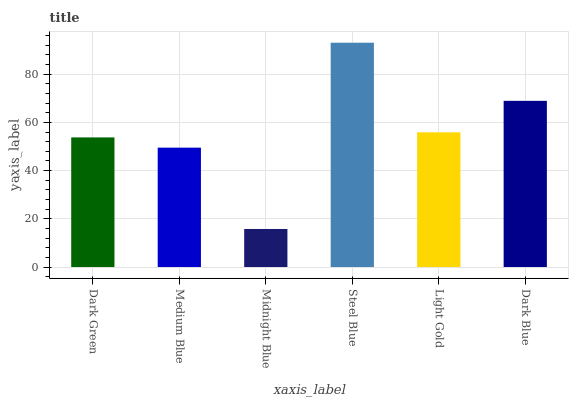Is Midnight Blue the minimum?
Answer yes or no. Yes. Is Steel Blue the maximum?
Answer yes or no. Yes. Is Medium Blue the minimum?
Answer yes or no. No. Is Medium Blue the maximum?
Answer yes or no. No. Is Dark Green greater than Medium Blue?
Answer yes or no. Yes. Is Medium Blue less than Dark Green?
Answer yes or no. Yes. Is Medium Blue greater than Dark Green?
Answer yes or no. No. Is Dark Green less than Medium Blue?
Answer yes or no. No. Is Light Gold the high median?
Answer yes or no. Yes. Is Dark Green the low median?
Answer yes or no. Yes. Is Medium Blue the high median?
Answer yes or no. No. Is Medium Blue the low median?
Answer yes or no. No. 